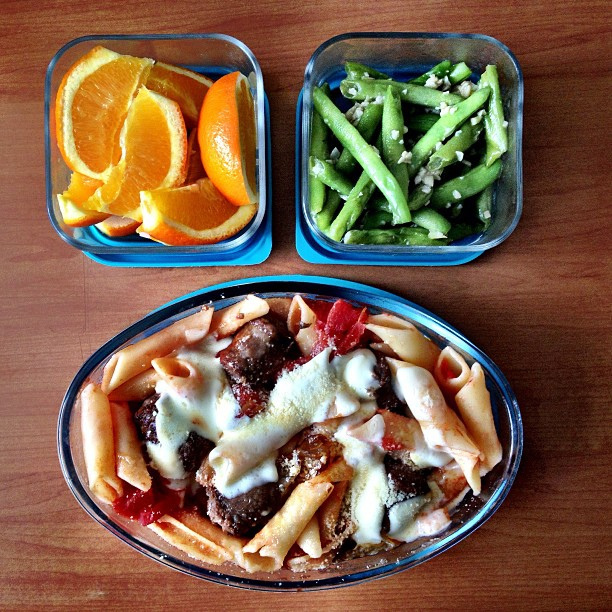What type of meal is shown in the image? The image displays a well-balanced meal consisting of a main dish of pasta with meatballs and sauce, a vegetable side of green beans, and a serving of orange slices for a fresh, fruity dessert. 